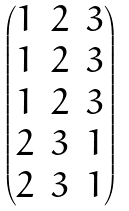Convert formula to latex. <formula><loc_0><loc_0><loc_500><loc_500>\begin{pmatrix} 1 & 2 & 3 \\ 1 & 2 & 3 \\ 1 & 2 & 3 \\ 2 & 3 & 1 \\ 2 & 3 & 1 \end{pmatrix}</formula> 